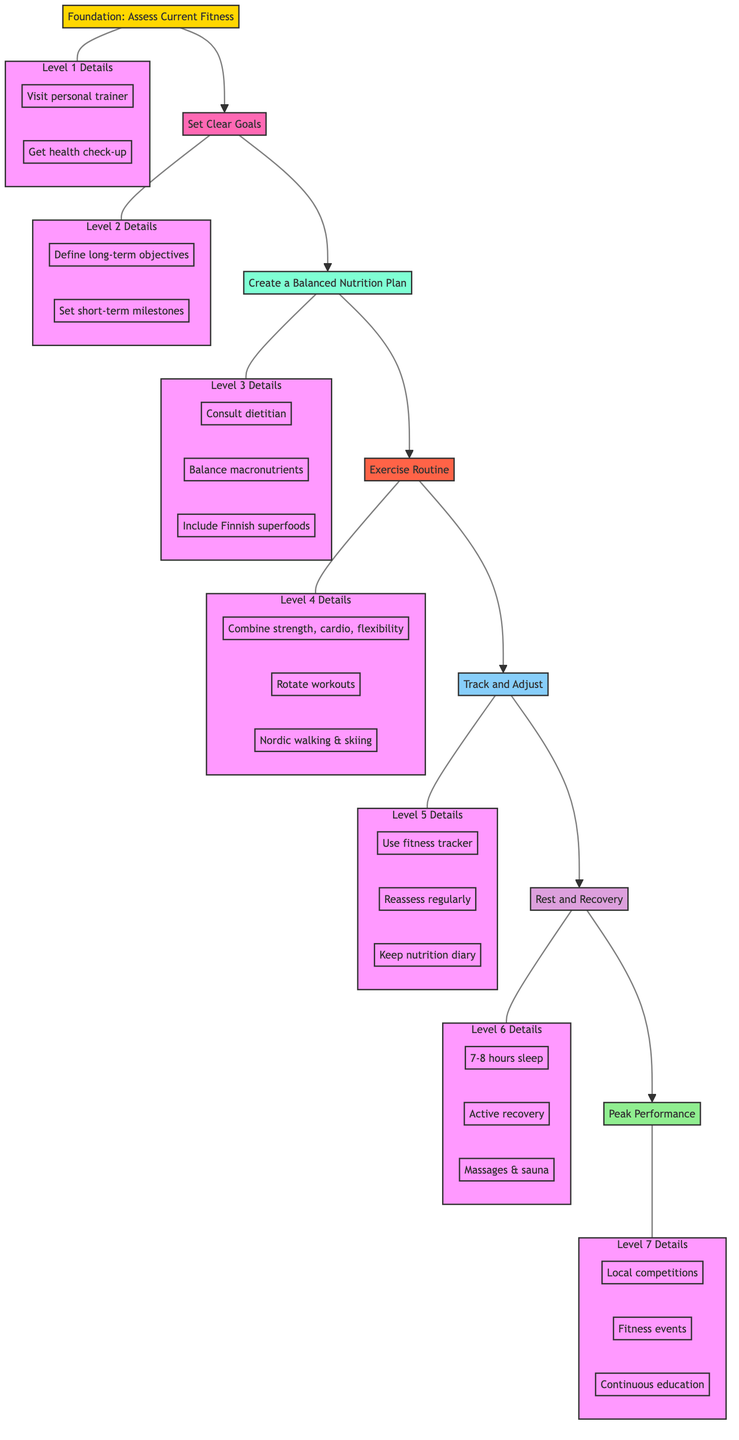What is the highest level in the diagram? The highest level is "Peak Performance," which appears at the top of the flow chart.
Answer: Peak Performance How many total levels are there in the diagram? By counting each distinct level from the bottom (Foundation) to the top (Peak Performance), there are 7 levels in total.
Answer: 7 What is the connection between "Create a Balanced Nutrition Plan" and "Exercise Routine"? The connection shows that "Create a Balanced Nutrition Plan" leads directly to "Exercise Routine," indicating that having a nutrition plan supplements exercise activities.
Answer: Direct connection Which level involves sleep and recovery? The level concerning sleep and recovery is "Rest and Recovery," which emphasizes the importance of sleep and relaxation in a fitness journey.
Answer: Rest and Recovery What type of activities are suggested under the "Exercise Routine" step? The "Exercise Routine" step includes a combination of strength training, cardio, and flexibility exercises.
Answer: Strength training, cardio, flexibility Which step follows "Set Clear Goals"? The step that follows "Set Clear Goals" is "Create a Balanced Nutrition Plan," showing the sequence of actions one should take after goal setting.
Answer: Create a Balanced Nutrition Plan What details are included under "Track and Adjust"? The details under "Track and Adjust" include using a fitness tracker, reassessing fitness levels, and keeping a nutrition diary.
Answer: Fitness tracker, reassessment, nutrition diary What local activities are mentioned in the "Peak Performance" level? The local activities mentioned in this level include participating in local competitions and engaging in events like the Helsinki Marathon.
Answer: Local competitions, Helsinki Marathon How often should workout routines be rotated according to the diagram? According to the diagram, workout routines should be rotated every 4-6 weeks to avoid fitness plateaus.
Answer: Every 4-6 weeks 